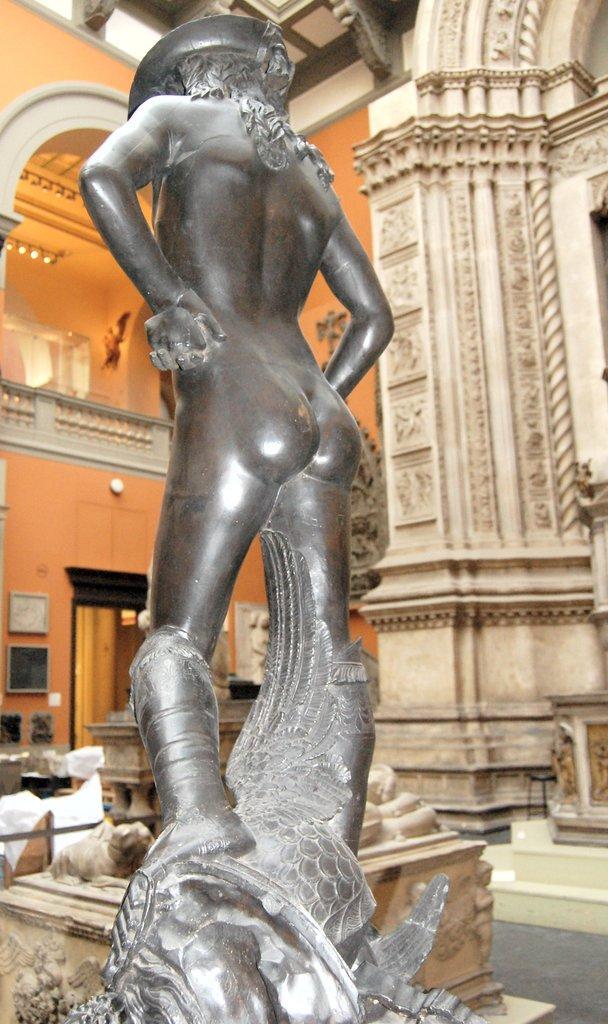Can you describe this image briefly? In this image I can see there is a statue of a human and it looks like an inside part of the fort. 